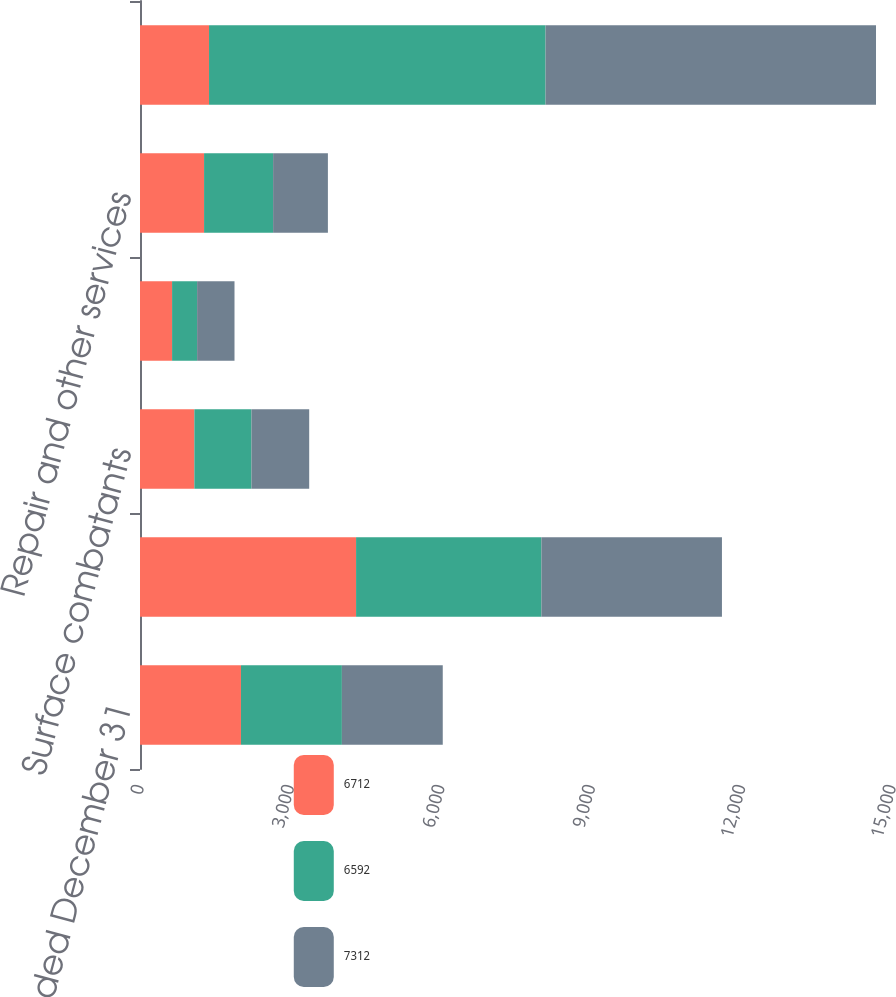Convert chart to OTSL. <chart><loc_0><loc_0><loc_500><loc_500><stacked_bar_chart><ecel><fcel>Year Ended December 31<fcel>Nuclear-powered submarines<fcel>Surface combatants<fcel>Auxiliary and commercial ships<fcel>Repair and other services<fcel>Total Marine Systems<nl><fcel>6712<fcel>2014<fcel>4310<fcel>1084<fcel>640<fcel>1278<fcel>1377<nl><fcel>6592<fcel>2013<fcel>3697<fcel>1139<fcel>499<fcel>1377<fcel>6712<nl><fcel>7312<fcel>2012<fcel>3601<fcel>1152<fcel>746<fcel>1093<fcel>6592<nl></chart> 